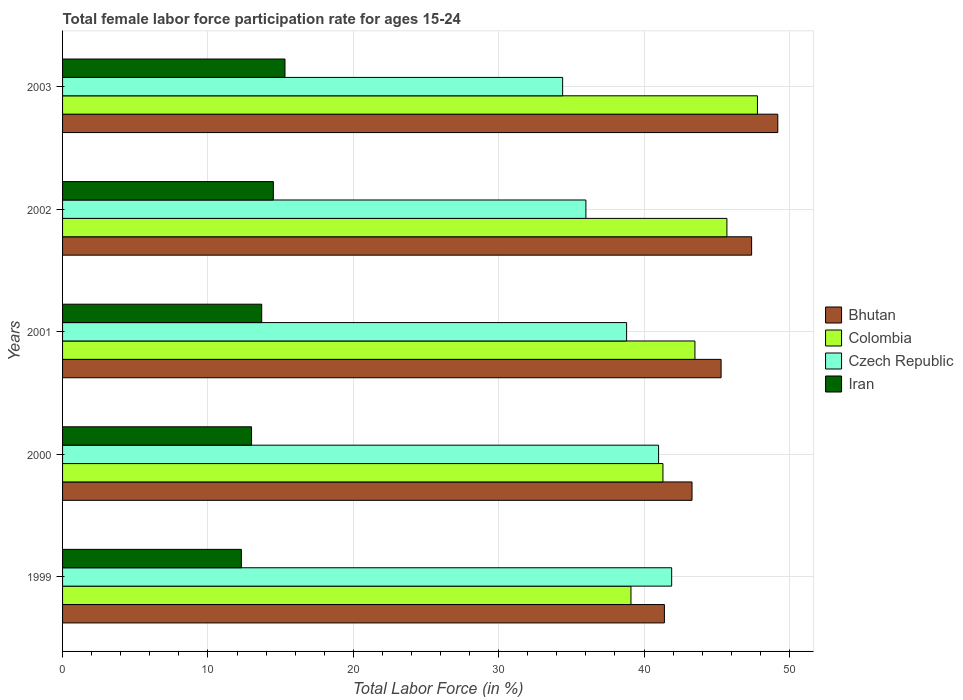How many groups of bars are there?
Give a very brief answer. 5. How many bars are there on the 5th tick from the top?
Give a very brief answer. 4. In how many cases, is the number of bars for a given year not equal to the number of legend labels?
Give a very brief answer. 0. What is the female labor force participation rate in Iran in 1999?
Keep it short and to the point. 12.3. Across all years, what is the maximum female labor force participation rate in Iran?
Ensure brevity in your answer.  15.3. Across all years, what is the minimum female labor force participation rate in Czech Republic?
Provide a short and direct response. 34.4. What is the total female labor force participation rate in Colombia in the graph?
Offer a terse response. 217.4. What is the difference between the female labor force participation rate in Iran in 2000 and that in 2001?
Provide a succinct answer. -0.7. What is the difference between the female labor force participation rate in Czech Republic in 1999 and the female labor force participation rate in Iran in 2003?
Provide a succinct answer. 26.6. What is the average female labor force participation rate in Colombia per year?
Provide a short and direct response. 43.48. In the year 2000, what is the difference between the female labor force participation rate in Iran and female labor force participation rate in Bhutan?
Give a very brief answer. -30.3. In how many years, is the female labor force participation rate in Colombia greater than 20 %?
Your answer should be compact. 5. What is the ratio of the female labor force participation rate in Czech Republic in 1999 to that in 2001?
Your answer should be very brief. 1.08. Is the difference between the female labor force participation rate in Iran in 2000 and 2003 greater than the difference between the female labor force participation rate in Bhutan in 2000 and 2003?
Your response must be concise. Yes. What is the difference between the highest and the second highest female labor force participation rate in Colombia?
Your answer should be compact. 2.1. What is the difference between the highest and the lowest female labor force participation rate in Colombia?
Give a very brief answer. 8.7. Is the sum of the female labor force participation rate in Czech Republic in 2001 and 2003 greater than the maximum female labor force participation rate in Colombia across all years?
Give a very brief answer. Yes. Is it the case that in every year, the sum of the female labor force participation rate in Czech Republic and female labor force participation rate in Colombia is greater than the sum of female labor force participation rate in Bhutan and female labor force participation rate in Iran?
Keep it short and to the point. No. What does the 4th bar from the top in 2000 represents?
Give a very brief answer. Bhutan. What does the 1st bar from the bottom in 2003 represents?
Your answer should be very brief. Bhutan. Is it the case that in every year, the sum of the female labor force participation rate in Czech Republic and female labor force participation rate in Colombia is greater than the female labor force participation rate in Iran?
Keep it short and to the point. Yes. How many bars are there?
Your response must be concise. 20. Are all the bars in the graph horizontal?
Keep it short and to the point. Yes. How many years are there in the graph?
Offer a very short reply. 5. What is the difference between two consecutive major ticks on the X-axis?
Provide a succinct answer. 10. Are the values on the major ticks of X-axis written in scientific E-notation?
Provide a short and direct response. No. Does the graph contain any zero values?
Ensure brevity in your answer.  No. How many legend labels are there?
Your answer should be compact. 4. What is the title of the graph?
Ensure brevity in your answer.  Total female labor force participation rate for ages 15-24. Does "Bolivia" appear as one of the legend labels in the graph?
Make the answer very short. No. What is the label or title of the Y-axis?
Keep it short and to the point. Years. What is the Total Labor Force (in %) of Bhutan in 1999?
Make the answer very short. 41.4. What is the Total Labor Force (in %) in Colombia in 1999?
Offer a terse response. 39.1. What is the Total Labor Force (in %) in Czech Republic in 1999?
Provide a succinct answer. 41.9. What is the Total Labor Force (in %) in Iran in 1999?
Your answer should be compact. 12.3. What is the Total Labor Force (in %) of Bhutan in 2000?
Make the answer very short. 43.3. What is the Total Labor Force (in %) of Colombia in 2000?
Your response must be concise. 41.3. What is the Total Labor Force (in %) of Czech Republic in 2000?
Provide a short and direct response. 41. What is the Total Labor Force (in %) in Iran in 2000?
Your answer should be very brief. 13. What is the Total Labor Force (in %) of Bhutan in 2001?
Make the answer very short. 45.3. What is the Total Labor Force (in %) of Colombia in 2001?
Ensure brevity in your answer.  43.5. What is the Total Labor Force (in %) in Czech Republic in 2001?
Your answer should be compact. 38.8. What is the Total Labor Force (in %) in Iran in 2001?
Your answer should be very brief. 13.7. What is the Total Labor Force (in %) of Bhutan in 2002?
Your answer should be very brief. 47.4. What is the Total Labor Force (in %) of Colombia in 2002?
Give a very brief answer. 45.7. What is the Total Labor Force (in %) of Czech Republic in 2002?
Your answer should be very brief. 36. What is the Total Labor Force (in %) in Iran in 2002?
Give a very brief answer. 14.5. What is the Total Labor Force (in %) of Bhutan in 2003?
Your response must be concise. 49.2. What is the Total Labor Force (in %) in Colombia in 2003?
Provide a succinct answer. 47.8. What is the Total Labor Force (in %) of Czech Republic in 2003?
Provide a succinct answer. 34.4. What is the Total Labor Force (in %) of Iran in 2003?
Give a very brief answer. 15.3. Across all years, what is the maximum Total Labor Force (in %) in Bhutan?
Provide a short and direct response. 49.2. Across all years, what is the maximum Total Labor Force (in %) of Colombia?
Offer a very short reply. 47.8. Across all years, what is the maximum Total Labor Force (in %) in Czech Republic?
Keep it short and to the point. 41.9. Across all years, what is the maximum Total Labor Force (in %) of Iran?
Make the answer very short. 15.3. Across all years, what is the minimum Total Labor Force (in %) in Bhutan?
Offer a terse response. 41.4. Across all years, what is the minimum Total Labor Force (in %) in Colombia?
Keep it short and to the point. 39.1. Across all years, what is the minimum Total Labor Force (in %) of Czech Republic?
Keep it short and to the point. 34.4. Across all years, what is the minimum Total Labor Force (in %) of Iran?
Your answer should be very brief. 12.3. What is the total Total Labor Force (in %) of Bhutan in the graph?
Ensure brevity in your answer.  226.6. What is the total Total Labor Force (in %) in Colombia in the graph?
Your answer should be compact. 217.4. What is the total Total Labor Force (in %) of Czech Republic in the graph?
Make the answer very short. 192.1. What is the total Total Labor Force (in %) in Iran in the graph?
Offer a terse response. 68.8. What is the difference between the Total Labor Force (in %) in Bhutan in 1999 and that in 2000?
Provide a succinct answer. -1.9. What is the difference between the Total Labor Force (in %) of Colombia in 1999 and that in 2000?
Provide a short and direct response. -2.2. What is the difference between the Total Labor Force (in %) of Czech Republic in 1999 and that in 2000?
Ensure brevity in your answer.  0.9. What is the difference between the Total Labor Force (in %) of Iran in 1999 and that in 2000?
Make the answer very short. -0.7. What is the difference between the Total Labor Force (in %) in Bhutan in 1999 and that in 2001?
Your answer should be compact. -3.9. What is the difference between the Total Labor Force (in %) in Czech Republic in 1999 and that in 2001?
Provide a succinct answer. 3.1. What is the difference between the Total Labor Force (in %) in Czech Republic in 1999 and that in 2002?
Provide a short and direct response. 5.9. What is the difference between the Total Labor Force (in %) of Colombia in 1999 and that in 2003?
Offer a terse response. -8.7. What is the difference between the Total Labor Force (in %) in Czech Republic in 1999 and that in 2003?
Your response must be concise. 7.5. What is the difference between the Total Labor Force (in %) in Bhutan in 2000 and that in 2001?
Make the answer very short. -2. What is the difference between the Total Labor Force (in %) in Czech Republic in 2000 and that in 2001?
Your answer should be very brief. 2.2. What is the difference between the Total Labor Force (in %) in Iran in 2000 and that in 2001?
Give a very brief answer. -0.7. What is the difference between the Total Labor Force (in %) of Bhutan in 2000 and that in 2002?
Offer a very short reply. -4.1. What is the difference between the Total Labor Force (in %) in Colombia in 2000 and that in 2003?
Make the answer very short. -6.5. What is the difference between the Total Labor Force (in %) of Bhutan in 2001 and that in 2002?
Provide a short and direct response. -2.1. What is the difference between the Total Labor Force (in %) of Colombia in 2001 and that in 2002?
Provide a succinct answer. -2.2. What is the difference between the Total Labor Force (in %) of Colombia in 2001 and that in 2003?
Provide a succinct answer. -4.3. What is the difference between the Total Labor Force (in %) of Czech Republic in 2001 and that in 2003?
Provide a short and direct response. 4.4. What is the difference between the Total Labor Force (in %) in Bhutan in 2002 and that in 2003?
Your answer should be compact. -1.8. What is the difference between the Total Labor Force (in %) in Bhutan in 1999 and the Total Labor Force (in %) in Iran in 2000?
Provide a short and direct response. 28.4. What is the difference between the Total Labor Force (in %) in Colombia in 1999 and the Total Labor Force (in %) in Iran in 2000?
Your answer should be compact. 26.1. What is the difference between the Total Labor Force (in %) in Czech Republic in 1999 and the Total Labor Force (in %) in Iran in 2000?
Make the answer very short. 28.9. What is the difference between the Total Labor Force (in %) of Bhutan in 1999 and the Total Labor Force (in %) of Colombia in 2001?
Your answer should be very brief. -2.1. What is the difference between the Total Labor Force (in %) in Bhutan in 1999 and the Total Labor Force (in %) in Iran in 2001?
Keep it short and to the point. 27.7. What is the difference between the Total Labor Force (in %) in Colombia in 1999 and the Total Labor Force (in %) in Iran in 2001?
Provide a short and direct response. 25.4. What is the difference between the Total Labor Force (in %) of Czech Republic in 1999 and the Total Labor Force (in %) of Iran in 2001?
Make the answer very short. 28.2. What is the difference between the Total Labor Force (in %) of Bhutan in 1999 and the Total Labor Force (in %) of Colombia in 2002?
Provide a short and direct response. -4.3. What is the difference between the Total Labor Force (in %) in Bhutan in 1999 and the Total Labor Force (in %) in Czech Republic in 2002?
Your answer should be very brief. 5.4. What is the difference between the Total Labor Force (in %) in Bhutan in 1999 and the Total Labor Force (in %) in Iran in 2002?
Your answer should be compact. 26.9. What is the difference between the Total Labor Force (in %) in Colombia in 1999 and the Total Labor Force (in %) in Czech Republic in 2002?
Your answer should be very brief. 3.1. What is the difference between the Total Labor Force (in %) in Colombia in 1999 and the Total Labor Force (in %) in Iran in 2002?
Keep it short and to the point. 24.6. What is the difference between the Total Labor Force (in %) in Czech Republic in 1999 and the Total Labor Force (in %) in Iran in 2002?
Provide a short and direct response. 27.4. What is the difference between the Total Labor Force (in %) in Bhutan in 1999 and the Total Labor Force (in %) in Colombia in 2003?
Provide a short and direct response. -6.4. What is the difference between the Total Labor Force (in %) of Bhutan in 1999 and the Total Labor Force (in %) of Iran in 2003?
Your response must be concise. 26.1. What is the difference between the Total Labor Force (in %) in Colombia in 1999 and the Total Labor Force (in %) in Iran in 2003?
Your response must be concise. 23.8. What is the difference between the Total Labor Force (in %) of Czech Republic in 1999 and the Total Labor Force (in %) of Iran in 2003?
Offer a very short reply. 26.6. What is the difference between the Total Labor Force (in %) of Bhutan in 2000 and the Total Labor Force (in %) of Czech Republic in 2001?
Your answer should be very brief. 4.5. What is the difference between the Total Labor Force (in %) in Bhutan in 2000 and the Total Labor Force (in %) in Iran in 2001?
Your response must be concise. 29.6. What is the difference between the Total Labor Force (in %) of Colombia in 2000 and the Total Labor Force (in %) of Iran in 2001?
Your response must be concise. 27.6. What is the difference between the Total Labor Force (in %) of Czech Republic in 2000 and the Total Labor Force (in %) of Iran in 2001?
Offer a very short reply. 27.3. What is the difference between the Total Labor Force (in %) of Bhutan in 2000 and the Total Labor Force (in %) of Iran in 2002?
Provide a short and direct response. 28.8. What is the difference between the Total Labor Force (in %) of Colombia in 2000 and the Total Labor Force (in %) of Czech Republic in 2002?
Give a very brief answer. 5.3. What is the difference between the Total Labor Force (in %) in Colombia in 2000 and the Total Labor Force (in %) in Iran in 2002?
Make the answer very short. 26.8. What is the difference between the Total Labor Force (in %) of Czech Republic in 2000 and the Total Labor Force (in %) of Iran in 2002?
Keep it short and to the point. 26.5. What is the difference between the Total Labor Force (in %) of Bhutan in 2000 and the Total Labor Force (in %) of Iran in 2003?
Ensure brevity in your answer.  28. What is the difference between the Total Labor Force (in %) in Czech Republic in 2000 and the Total Labor Force (in %) in Iran in 2003?
Your answer should be very brief. 25.7. What is the difference between the Total Labor Force (in %) in Bhutan in 2001 and the Total Labor Force (in %) in Colombia in 2002?
Ensure brevity in your answer.  -0.4. What is the difference between the Total Labor Force (in %) in Bhutan in 2001 and the Total Labor Force (in %) in Iran in 2002?
Offer a very short reply. 30.8. What is the difference between the Total Labor Force (in %) of Czech Republic in 2001 and the Total Labor Force (in %) of Iran in 2002?
Provide a short and direct response. 24.3. What is the difference between the Total Labor Force (in %) in Bhutan in 2001 and the Total Labor Force (in %) in Iran in 2003?
Make the answer very short. 30. What is the difference between the Total Labor Force (in %) in Colombia in 2001 and the Total Labor Force (in %) in Czech Republic in 2003?
Keep it short and to the point. 9.1. What is the difference between the Total Labor Force (in %) of Colombia in 2001 and the Total Labor Force (in %) of Iran in 2003?
Your answer should be compact. 28.2. What is the difference between the Total Labor Force (in %) of Bhutan in 2002 and the Total Labor Force (in %) of Iran in 2003?
Give a very brief answer. 32.1. What is the difference between the Total Labor Force (in %) in Colombia in 2002 and the Total Labor Force (in %) in Iran in 2003?
Your answer should be compact. 30.4. What is the difference between the Total Labor Force (in %) in Czech Republic in 2002 and the Total Labor Force (in %) in Iran in 2003?
Offer a very short reply. 20.7. What is the average Total Labor Force (in %) of Bhutan per year?
Your answer should be very brief. 45.32. What is the average Total Labor Force (in %) in Colombia per year?
Ensure brevity in your answer.  43.48. What is the average Total Labor Force (in %) of Czech Republic per year?
Ensure brevity in your answer.  38.42. What is the average Total Labor Force (in %) in Iran per year?
Provide a short and direct response. 13.76. In the year 1999, what is the difference between the Total Labor Force (in %) in Bhutan and Total Labor Force (in %) in Colombia?
Make the answer very short. 2.3. In the year 1999, what is the difference between the Total Labor Force (in %) of Bhutan and Total Labor Force (in %) of Czech Republic?
Make the answer very short. -0.5. In the year 1999, what is the difference between the Total Labor Force (in %) of Bhutan and Total Labor Force (in %) of Iran?
Offer a very short reply. 29.1. In the year 1999, what is the difference between the Total Labor Force (in %) of Colombia and Total Labor Force (in %) of Iran?
Your response must be concise. 26.8. In the year 1999, what is the difference between the Total Labor Force (in %) of Czech Republic and Total Labor Force (in %) of Iran?
Your answer should be very brief. 29.6. In the year 2000, what is the difference between the Total Labor Force (in %) in Bhutan and Total Labor Force (in %) in Colombia?
Offer a very short reply. 2. In the year 2000, what is the difference between the Total Labor Force (in %) of Bhutan and Total Labor Force (in %) of Czech Republic?
Your answer should be very brief. 2.3. In the year 2000, what is the difference between the Total Labor Force (in %) of Bhutan and Total Labor Force (in %) of Iran?
Keep it short and to the point. 30.3. In the year 2000, what is the difference between the Total Labor Force (in %) of Colombia and Total Labor Force (in %) of Iran?
Your answer should be compact. 28.3. In the year 2000, what is the difference between the Total Labor Force (in %) in Czech Republic and Total Labor Force (in %) in Iran?
Keep it short and to the point. 28. In the year 2001, what is the difference between the Total Labor Force (in %) in Bhutan and Total Labor Force (in %) in Colombia?
Provide a succinct answer. 1.8. In the year 2001, what is the difference between the Total Labor Force (in %) in Bhutan and Total Labor Force (in %) in Czech Republic?
Offer a very short reply. 6.5. In the year 2001, what is the difference between the Total Labor Force (in %) of Bhutan and Total Labor Force (in %) of Iran?
Offer a very short reply. 31.6. In the year 2001, what is the difference between the Total Labor Force (in %) of Colombia and Total Labor Force (in %) of Czech Republic?
Ensure brevity in your answer.  4.7. In the year 2001, what is the difference between the Total Labor Force (in %) of Colombia and Total Labor Force (in %) of Iran?
Your answer should be very brief. 29.8. In the year 2001, what is the difference between the Total Labor Force (in %) of Czech Republic and Total Labor Force (in %) of Iran?
Make the answer very short. 25.1. In the year 2002, what is the difference between the Total Labor Force (in %) of Bhutan and Total Labor Force (in %) of Iran?
Your answer should be very brief. 32.9. In the year 2002, what is the difference between the Total Labor Force (in %) of Colombia and Total Labor Force (in %) of Iran?
Provide a succinct answer. 31.2. In the year 2003, what is the difference between the Total Labor Force (in %) in Bhutan and Total Labor Force (in %) in Colombia?
Offer a terse response. 1.4. In the year 2003, what is the difference between the Total Labor Force (in %) in Bhutan and Total Labor Force (in %) in Czech Republic?
Ensure brevity in your answer.  14.8. In the year 2003, what is the difference between the Total Labor Force (in %) in Bhutan and Total Labor Force (in %) in Iran?
Give a very brief answer. 33.9. In the year 2003, what is the difference between the Total Labor Force (in %) in Colombia and Total Labor Force (in %) in Iran?
Ensure brevity in your answer.  32.5. What is the ratio of the Total Labor Force (in %) in Bhutan in 1999 to that in 2000?
Ensure brevity in your answer.  0.96. What is the ratio of the Total Labor Force (in %) of Colombia in 1999 to that in 2000?
Your answer should be compact. 0.95. What is the ratio of the Total Labor Force (in %) in Czech Republic in 1999 to that in 2000?
Provide a short and direct response. 1.02. What is the ratio of the Total Labor Force (in %) of Iran in 1999 to that in 2000?
Offer a very short reply. 0.95. What is the ratio of the Total Labor Force (in %) of Bhutan in 1999 to that in 2001?
Provide a short and direct response. 0.91. What is the ratio of the Total Labor Force (in %) of Colombia in 1999 to that in 2001?
Your response must be concise. 0.9. What is the ratio of the Total Labor Force (in %) in Czech Republic in 1999 to that in 2001?
Give a very brief answer. 1.08. What is the ratio of the Total Labor Force (in %) in Iran in 1999 to that in 2001?
Provide a short and direct response. 0.9. What is the ratio of the Total Labor Force (in %) of Bhutan in 1999 to that in 2002?
Provide a succinct answer. 0.87. What is the ratio of the Total Labor Force (in %) of Colombia in 1999 to that in 2002?
Make the answer very short. 0.86. What is the ratio of the Total Labor Force (in %) in Czech Republic in 1999 to that in 2002?
Make the answer very short. 1.16. What is the ratio of the Total Labor Force (in %) of Iran in 1999 to that in 2002?
Make the answer very short. 0.85. What is the ratio of the Total Labor Force (in %) of Bhutan in 1999 to that in 2003?
Offer a very short reply. 0.84. What is the ratio of the Total Labor Force (in %) in Colombia in 1999 to that in 2003?
Your response must be concise. 0.82. What is the ratio of the Total Labor Force (in %) of Czech Republic in 1999 to that in 2003?
Your answer should be very brief. 1.22. What is the ratio of the Total Labor Force (in %) in Iran in 1999 to that in 2003?
Your answer should be very brief. 0.8. What is the ratio of the Total Labor Force (in %) in Bhutan in 2000 to that in 2001?
Your answer should be compact. 0.96. What is the ratio of the Total Labor Force (in %) in Colombia in 2000 to that in 2001?
Offer a terse response. 0.95. What is the ratio of the Total Labor Force (in %) of Czech Republic in 2000 to that in 2001?
Provide a succinct answer. 1.06. What is the ratio of the Total Labor Force (in %) of Iran in 2000 to that in 2001?
Keep it short and to the point. 0.95. What is the ratio of the Total Labor Force (in %) of Bhutan in 2000 to that in 2002?
Offer a very short reply. 0.91. What is the ratio of the Total Labor Force (in %) of Colombia in 2000 to that in 2002?
Your answer should be very brief. 0.9. What is the ratio of the Total Labor Force (in %) in Czech Republic in 2000 to that in 2002?
Provide a short and direct response. 1.14. What is the ratio of the Total Labor Force (in %) of Iran in 2000 to that in 2002?
Provide a succinct answer. 0.9. What is the ratio of the Total Labor Force (in %) of Bhutan in 2000 to that in 2003?
Keep it short and to the point. 0.88. What is the ratio of the Total Labor Force (in %) in Colombia in 2000 to that in 2003?
Ensure brevity in your answer.  0.86. What is the ratio of the Total Labor Force (in %) in Czech Republic in 2000 to that in 2003?
Ensure brevity in your answer.  1.19. What is the ratio of the Total Labor Force (in %) in Iran in 2000 to that in 2003?
Your answer should be very brief. 0.85. What is the ratio of the Total Labor Force (in %) in Bhutan in 2001 to that in 2002?
Offer a terse response. 0.96. What is the ratio of the Total Labor Force (in %) in Colombia in 2001 to that in 2002?
Provide a succinct answer. 0.95. What is the ratio of the Total Labor Force (in %) of Czech Republic in 2001 to that in 2002?
Give a very brief answer. 1.08. What is the ratio of the Total Labor Force (in %) of Iran in 2001 to that in 2002?
Offer a terse response. 0.94. What is the ratio of the Total Labor Force (in %) of Bhutan in 2001 to that in 2003?
Your answer should be compact. 0.92. What is the ratio of the Total Labor Force (in %) of Colombia in 2001 to that in 2003?
Your answer should be compact. 0.91. What is the ratio of the Total Labor Force (in %) of Czech Republic in 2001 to that in 2003?
Keep it short and to the point. 1.13. What is the ratio of the Total Labor Force (in %) of Iran in 2001 to that in 2003?
Give a very brief answer. 0.9. What is the ratio of the Total Labor Force (in %) in Bhutan in 2002 to that in 2003?
Offer a very short reply. 0.96. What is the ratio of the Total Labor Force (in %) in Colombia in 2002 to that in 2003?
Offer a very short reply. 0.96. What is the ratio of the Total Labor Force (in %) of Czech Republic in 2002 to that in 2003?
Make the answer very short. 1.05. What is the ratio of the Total Labor Force (in %) of Iran in 2002 to that in 2003?
Make the answer very short. 0.95. What is the difference between the highest and the second highest Total Labor Force (in %) of Bhutan?
Offer a terse response. 1.8. What is the difference between the highest and the second highest Total Labor Force (in %) in Colombia?
Make the answer very short. 2.1. What is the difference between the highest and the second highest Total Labor Force (in %) of Iran?
Provide a succinct answer. 0.8. What is the difference between the highest and the lowest Total Labor Force (in %) in Bhutan?
Offer a terse response. 7.8. What is the difference between the highest and the lowest Total Labor Force (in %) of Colombia?
Your answer should be very brief. 8.7. What is the difference between the highest and the lowest Total Labor Force (in %) of Iran?
Offer a very short reply. 3. 